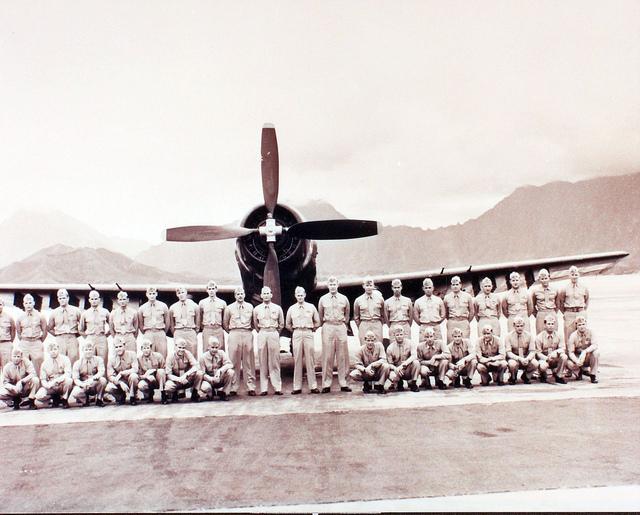Is this a vintage military photo?
Answer briefly. Yes. Are all the men standing?
Write a very short answer. No. What is in the background?
Answer briefly. Mountains. 